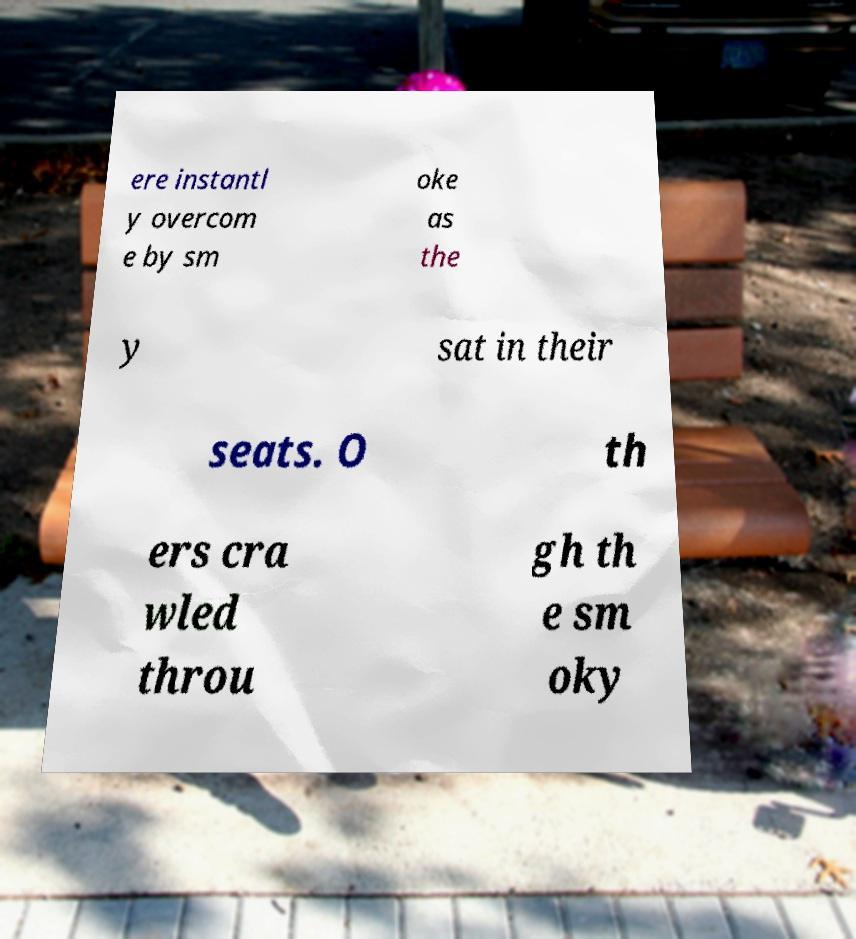Can you read and provide the text displayed in the image?This photo seems to have some interesting text. Can you extract and type it out for me? ere instantl y overcom e by sm oke as the y sat in their seats. O th ers cra wled throu gh th e sm oky 